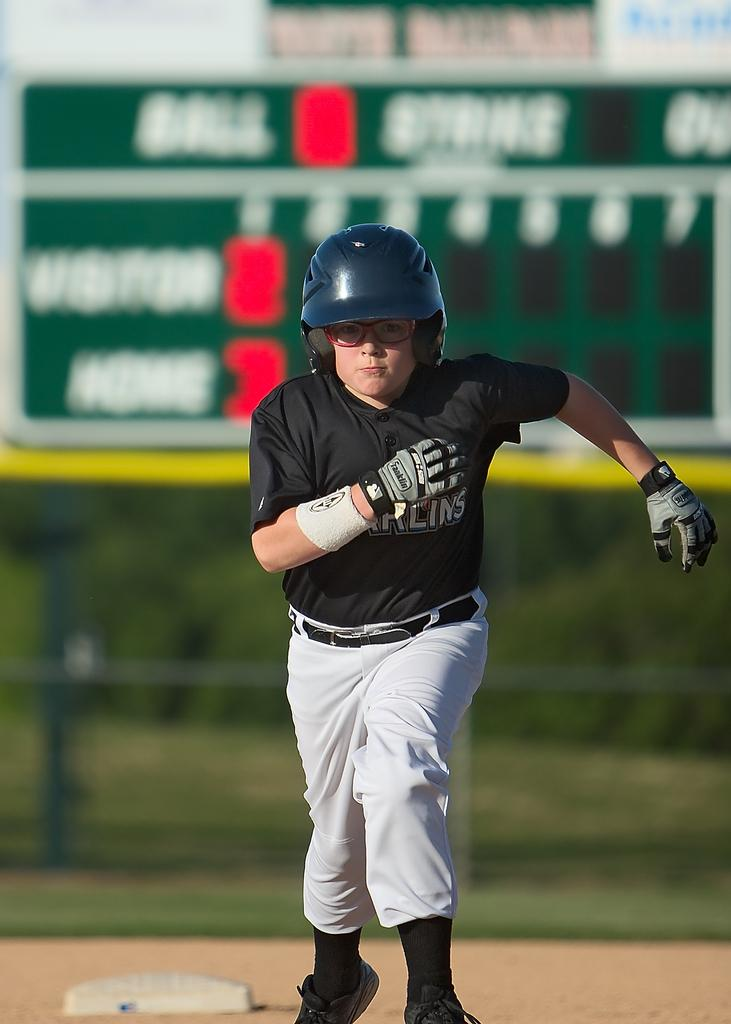<image>
Offer a succinct explanation of the picture presented. The gloves that the baseball player is wearing are from Franklin 